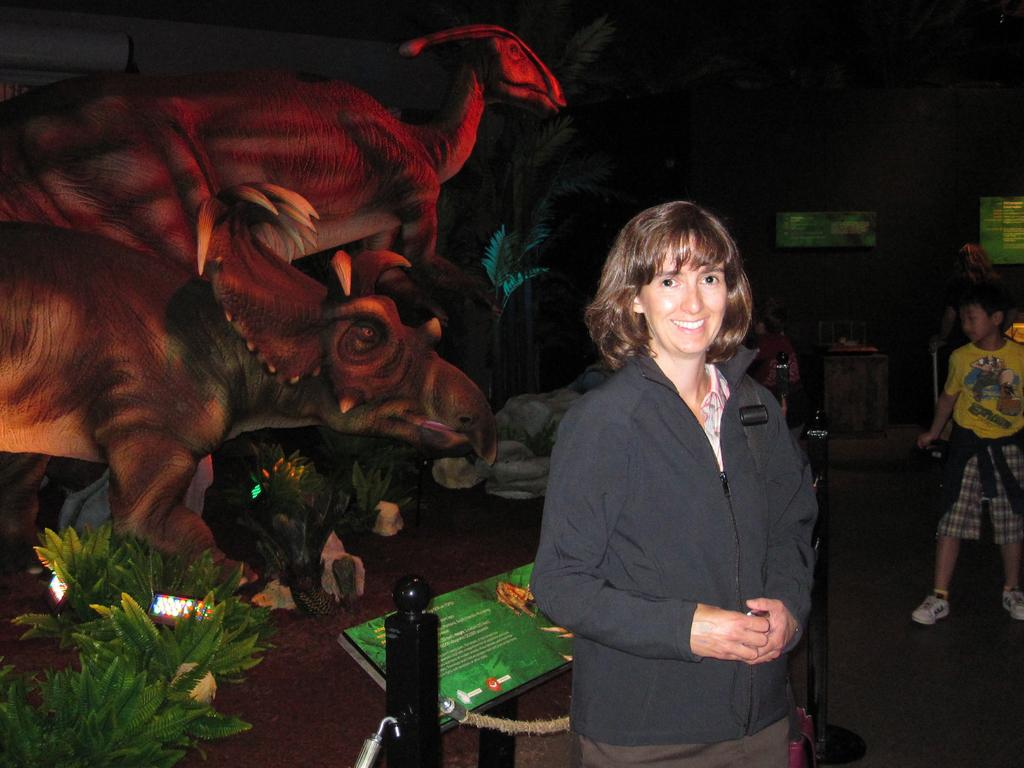What is the woman in the image doing? The woman in the image is giving a pose for a photograph. What can be seen in the background of the image? There are dinosaur sculptures and plants in the background of the image. Where is the boy located in the image? The boy is standing on the right side of the image. What type of planes can be seen flying in the image? There are no planes visible in the image; the image features a woman posing for a photograph with dinosaur sculptures and plants in the background. 